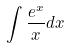Convert formula to latex. <formula><loc_0><loc_0><loc_500><loc_500>\int \frac { e ^ { x } } { x } d x</formula> 